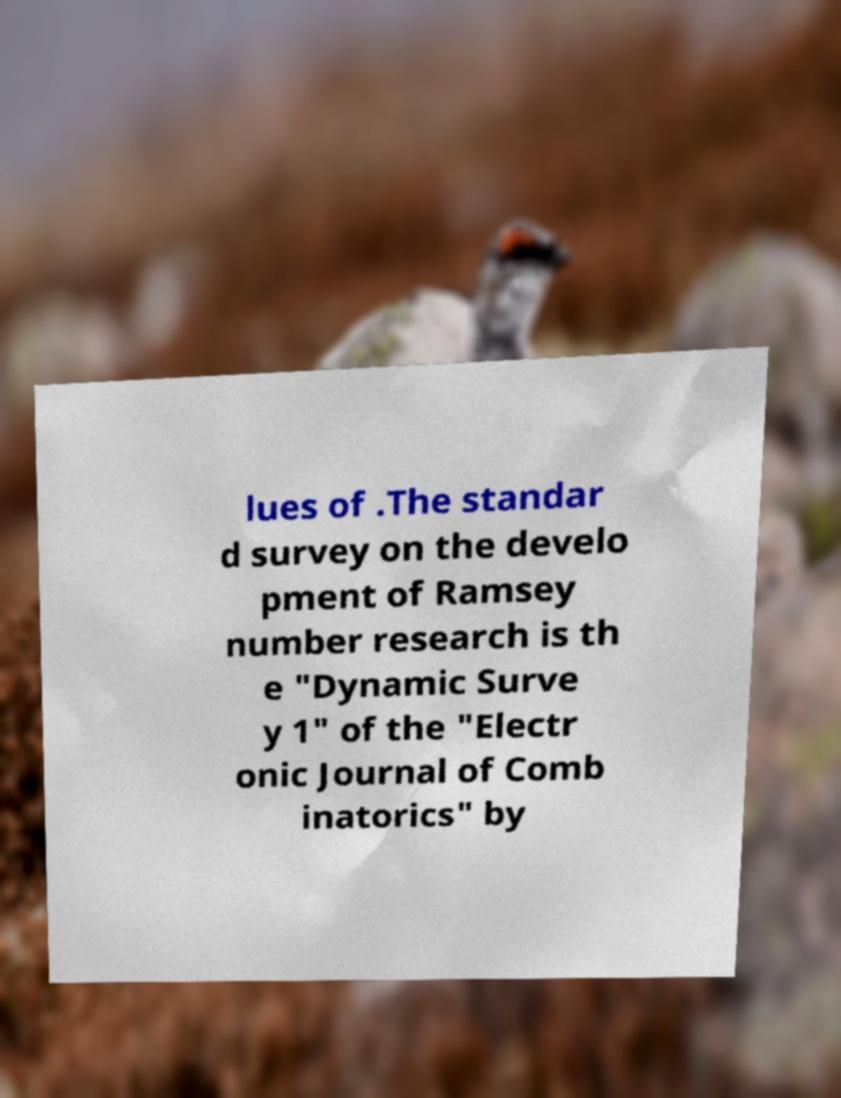Please identify and transcribe the text found in this image. lues of .The standar d survey on the develo pment of Ramsey number research is th e "Dynamic Surve y 1" of the "Electr onic Journal of Comb inatorics" by 